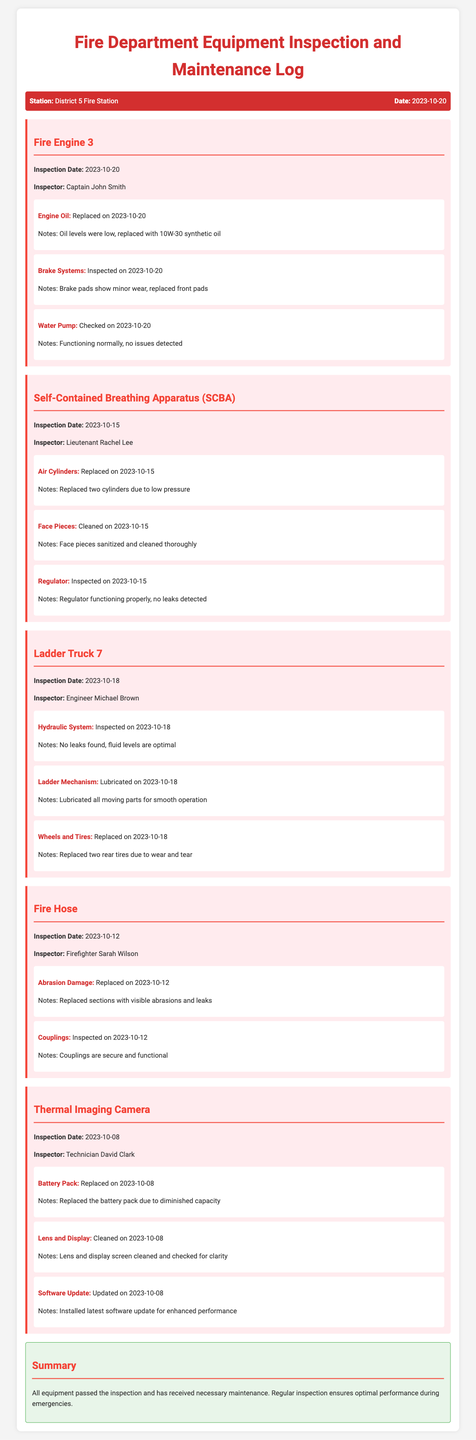What is the inspection date for Fire Engine 3? The inspection date for Fire Engine 3 is stated in the document as 2023-10-20.
Answer: 2023-10-20 Who inspected the Self-Contained Breathing Apparatus? The name of the inspector for the Self-Contained Breathing Apparatus is mentioned in the document as Lieutenant Rachel Lee.
Answer: Lieutenant Rachel Lee What part was replaced on Ladder Truck 7? The document specifies that two rear tires were replaced due to wear and tear on Ladder Truck 7.
Answer: Two rear tires What was the result of the thermal imaging camera's battery inspection? The document indicates that the battery pack of the thermal imaging camera was replaced due to diminished capacity.
Answer: Replaced How many air cylinders were replaced for the SCBA? According to the document, two air cylinders were replaced due to low pressure during the maintenance check.
Answer: Two cylinders What color is the background of the summary section? The color of the background for the summary section is indicated in the document as green.
Answer: Green What was the outcome of the fire equipment inspections? The summary in the document states that all equipment passed the inspection and received necessary maintenance.
Answer: Passed When was the last maintenance check for the fire hose conducted? The document shows that the last maintenance check for the fire hose was conducted on 2023-10-12.
Answer: 2023-10-12 Which inspector inspected Ladder Truck 7? The document identifies Engineer Michael Brown as the inspector for Ladder Truck 7.
Answer: Engineer Michael Brown 